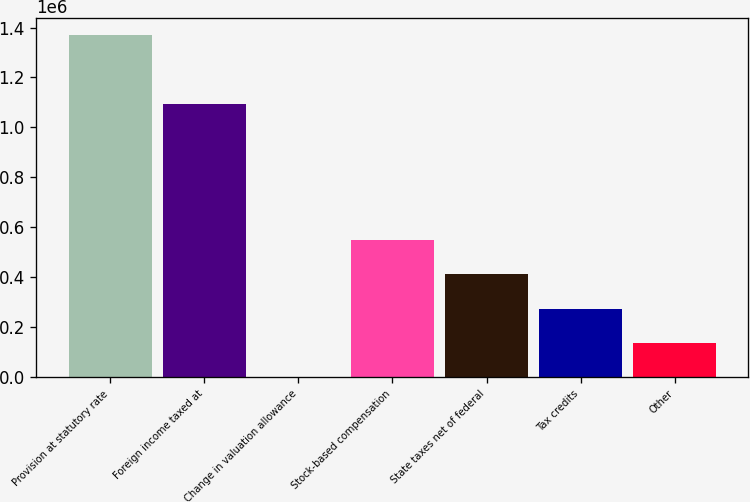<chart> <loc_0><loc_0><loc_500><loc_500><bar_chart><fcel>Provision at statutory rate<fcel>Foreign income taxed at<fcel>Change in valuation allowance<fcel>Stock-based compensation<fcel>State taxes net of federal<fcel>Tax credits<fcel>Other<nl><fcel>1.36852e+06<fcel>1.09351e+06<fcel>787<fcel>547879<fcel>411106<fcel>274333<fcel>137560<nl></chart> 